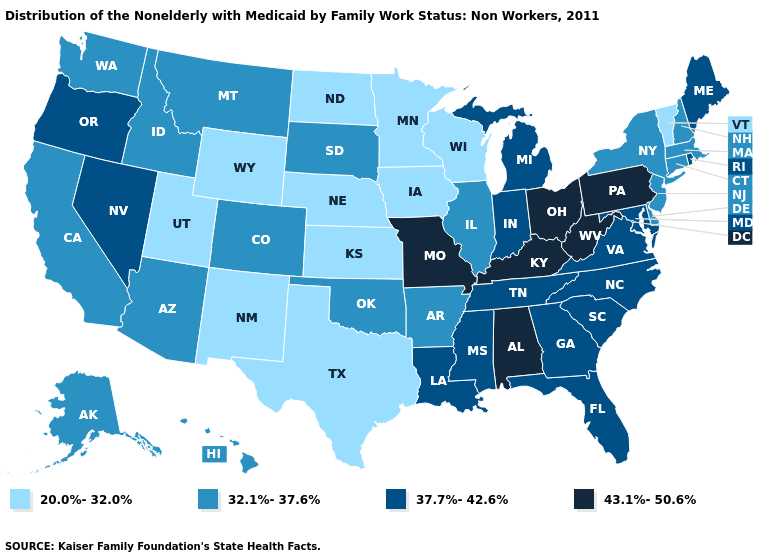Among the states that border Washington , does Oregon have the lowest value?
Short answer required. No. Among the states that border Michigan , does Ohio have the highest value?
Concise answer only. Yes. Among the states that border Iowa , does Nebraska have the highest value?
Answer briefly. No. Does Alabama have the highest value in the USA?
Answer briefly. Yes. What is the value of Rhode Island?
Short answer required. 37.7%-42.6%. Which states have the lowest value in the USA?
Write a very short answer. Iowa, Kansas, Minnesota, Nebraska, New Mexico, North Dakota, Texas, Utah, Vermont, Wisconsin, Wyoming. Which states have the highest value in the USA?
Give a very brief answer. Alabama, Kentucky, Missouri, Ohio, Pennsylvania, West Virginia. What is the value of Oklahoma?
Be succinct. 32.1%-37.6%. Among the states that border Indiana , which have the lowest value?
Keep it brief. Illinois. Name the states that have a value in the range 43.1%-50.6%?
Give a very brief answer. Alabama, Kentucky, Missouri, Ohio, Pennsylvania, West Virginia. What is the value of Kentucky?
Concise answer only. 43.1%-50.6%. Among the states that border New Mexico , does Texas have the lowest value?
Short answer required. Yes. What is the value of Massachusetts?
Keep it brief. 32.1%-37.6%. Name the states that have a value in the range 43.1%-50.6%?
Quick response, please. Alabama, Kentucky, Missouri, Ohio, Pennsylvania, West Virginia. 